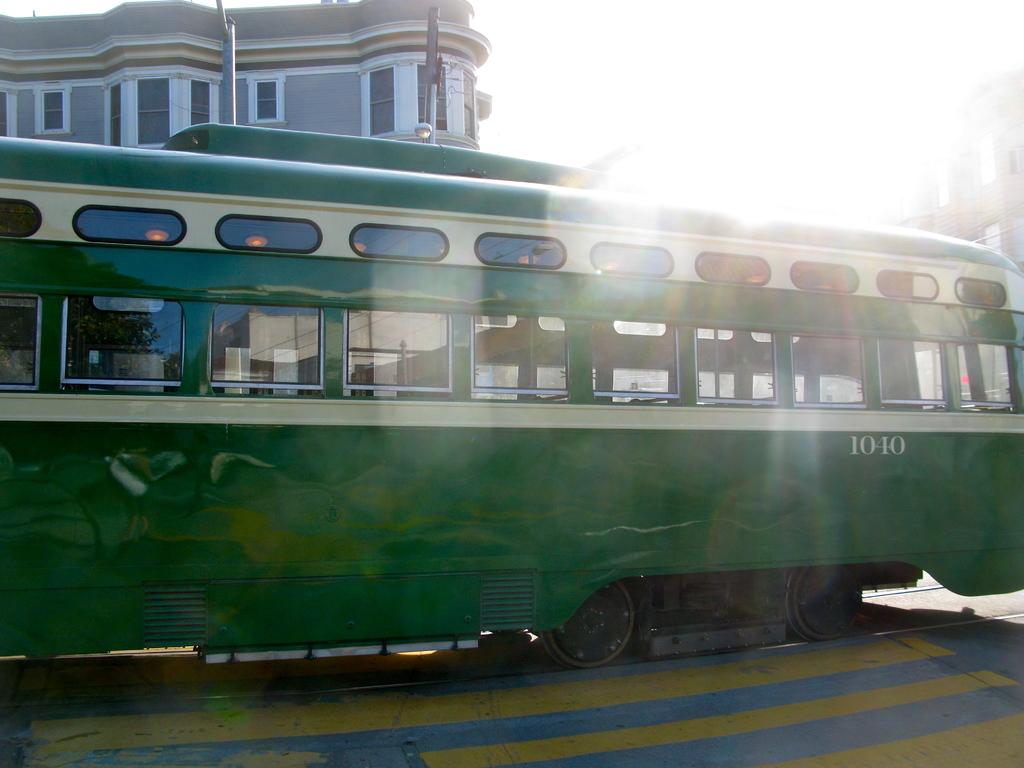What is this trolleys number?
Provide a succinct answer. 1010. 